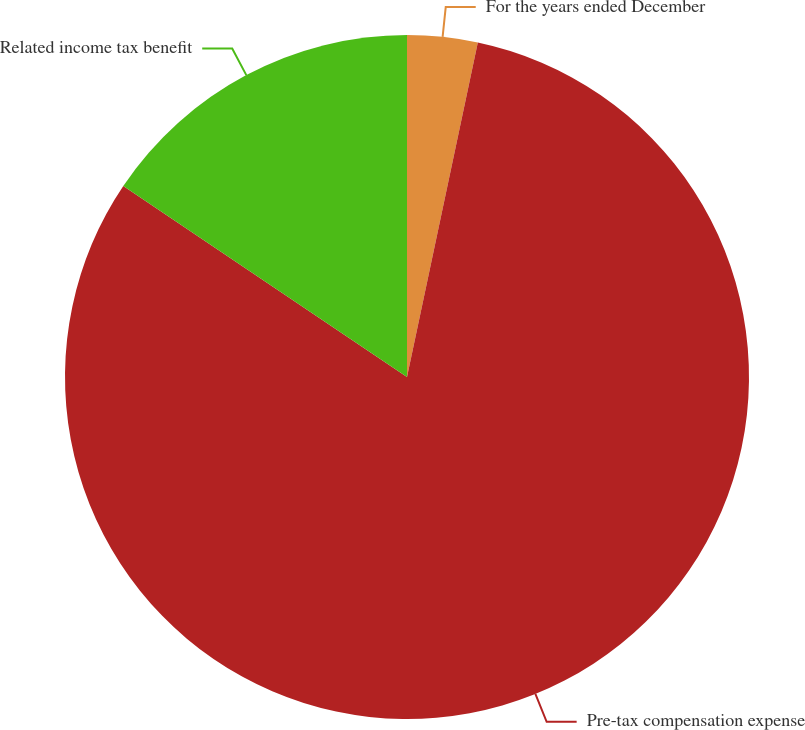<chart> <loc_0><loc_0><loc_500><loc_500><pie_chart><fcel>For the years ended December<fcel>Pre-tax compensation expense<fcel>Related income tax benefit<nl><fcel>3.32%<fcel>81.11%<fcel>15.57%<nl></chart> 